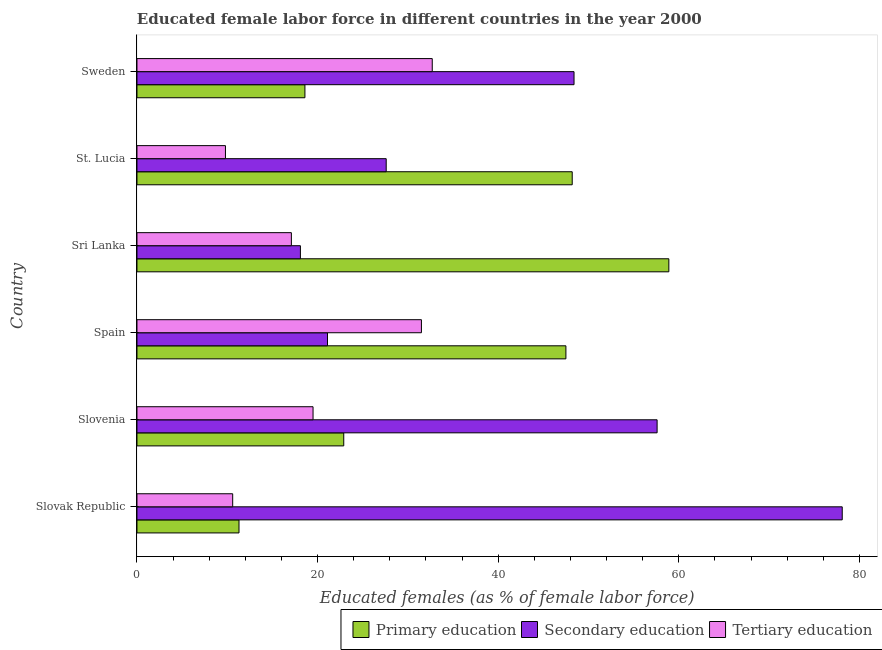Are the number of bars per tick equal to the number of legend labels?
Keep it short and to the point. Yes. How many bars are there on the 4th tick from the bottom?
Make the answer very short. 3. What is the label of the 2nd group of bars from the top?
Make the answer very short. St. Lucia. In how many cases, is the number of bars for a given country not equal to the number of legend labels?
Provide a short and direct response. 0. What is the percentage of female labor force who received secondary education in Sweden?
Provide a short and direct response. 48.4. Across all countries, what is the maximum percentage of female labor force who received tertiary education?
Your response must be concise. 32.7. Across all countries, what is the minimum percentage of female labor force who received secondary education?
Provide a short and direct response. 18.1. In which country was the percentage of female labor force who received secondary education maximum?
Make the answer very short. Slovak Republic. In which country was the percentage of female labor force who received tertiary education minimum?
Offer a terse response. St. Lucia. What is the total percentage of female labor force who received secondary education in the graph?
Ensure brevity in your answer.  250.9. What is the difference between the percentage of female labor force who received primary education in Sri Lanka and that in St. Lucia?
Provide a succinct answer. 10.7. What is the difference between the percentage of female labor force who received tertiary education in Sweden and the percentage of female labor force who received secondary education in Spain?
Offer a terse response. 11.6. What is the average percentage of female labor force who received tertiary education per country?
Provide a succinct answer. 20.2. What is the difference between the percentage of female labor force who received secondary education and percentage of female labor force who received primary education in Sri Lanka?
Your answer should be compact. -40.8. In how many countries, is the percentage of female labor force who received tertiary education greater than 64 %?
Keep it short and to the point. 0. What is the ratio of the percentage of female labor force who received secondary education in Spain to that in Sweden?
Your response must be concise. 0.44. Is the percentage of female labor force who received tertiary education in Sri Lanka less than that in Sweden?
Give a very brief answer. Yes. What is the difference between the highest and the second highest percentage of female labor force who received tertiary education?
Keep it short and to the point. 1.2. What is the difference between the highest and the lowest percentage of female labor force who received secondary education?
Ensure brevity in your answer.  60. What does the 1st bar from the top in Slovak Republic represents?
Offer a very short reply. Tertiary education. What does the 2nd bar from the bottom in Spain represents?
Provide a short and direct response. Secondary education. How many countries are there in the graph?
Make the answer very short. 6. What is the difference between two consecutive major ticks on the X-axis?
Give a very brief answer. 20. Are the values on the major ticks of X-axis written in scientific E-notation?
Provide a short and direct response. No. Does the graph contain any zero values?
Ensure brevity in your answer.  No. Where does the legend appear in the graph?
Provide a succinct answer. Bottom right. What is the title of the graph?
Make the answer very short. Educated female labor force in different countries in the year 2000. What is the label or title of the X-axis?
Keep it short and to the point. Educated females (as % of female labor force). What is the Educated females (as % of female labor force) of Primary education in Slovak Republic?
Your answer should be very brief. 11.3. What is the Educated females (as % of female labor force) in Secondary education in Slovak Republic?
Ensure brevity in your answer.  78.1. What is the Educated females (as % of female labor force) of Tertiary education in Slovak Republic?
Offer a terse response. 10.6. What is the Educated females (as % of female labor force) of Primary education in Slovenia?
Give a very brief answer. 22.9. What is the Educated females (as % of female labor force) of Secondary education in Slovenia?
Provide a succinct answer. 57.6. What is the Educated females (as % of female labor force) of Primary education in Spain?
Give a very brief answer. 47.5. What is the Educated females (as % of female labor force) of Secondary education in Spain?
Your answer should be compact. 21.1. What is the Educated females (as % of female labor force) of Tertiary education in Spain?
Offer a terse response. 31.5. What is the Educated females (as % of female labor force) of Primary education in Sri Lanka?
Offer a terse response. 58.9. What is the Educated females (as % of female labor force) of Secondary education in Sri Lanka?
Your response must be concise. 18.1. What is the Educated females (as % of female labor force) in Tertiary education in Sri Lanka?
Your answer should be compact. 17.1. What is the Educated females (as % of female labor force) in Primary education in St. Lucia?
Provide a short and direct response. 48.2. What is the Educated females (as % of female labor force) in Secondary education in St. Lucia?
Your response must be concise. 27.6. What is the Educated females (as % of female labor force) in Tertiary education in St. Lucia?
Offer a terse response. 9.8. What is the Educated females (as % of female labor force) in Primary education in Sweden?
Your answer should be compact. 18.6. What is the Educated females (as % of female labor force) in Secondary education in Sweden?
Provide a succinct answer. 48.4. What is the Educated females (as % of female labor force) of Tertiary education in Sweden?
Ensure brevity in your answer.  32.7. Across all countries, what is the maximum Educated females (as % of female labor force) in Primary education?
Ensure brevity in your answer.  58.9. Across all countries, what is the maximum Educated females (as % of female labor force) of Secondary education?
Keep it short and to the point. 78.1. Across all countries, what is the maximum Educated females (as % of female labor force) in Tertiary education?
Make the answer very short. 32.7. Across all countries, what is the minimum Educated females (as % of female labor force) in Primary education?
Your answer should be compact. 11.3. Across all countries, what is the minimum Educated females (as % of female labor force) in Secondary education?
Offer a terse response. 18.1. Across all countries, what is the minimum Educated females (as % of female labor force) in Tertiary education?
Provide a succinct answer. 9.8. What is the total Educated females (as % of female labor force) in Primary education in the graph?
Your answer should be very brief. 207.4. What is the total Educated females (as % of female labor force) of Secondary education in the graph?
Your response must be concise. 250.9. What is the total Educated females (as % of female labor force) of Tertiary education in the graph?
Your answer should be very brief. 121.2. What is the difference between the Educated females (as % of female labor force) in Primary education in Slovak Republic and that in Slovenia?
Keep it short and to the point. -11.6. What is the difference between the Educated females (as % of female labor force) of Tertiary education in Slovak Republic and that in Slovenia?
Offer a terse response. -8.9. What is the difference between the Educated females (as % of female labor force) in Primary education in Slovak Republic and that in Spain?
Your response must be concise. -36.2. What is the difference between the Educated females (as % of female labor force) in Secondary education in Slovak Republic and that in Spain?
Ensure brevity in your answer.  57. What is the difference between the Educated females (as % of female labor force) in Tertiary education in Slovak Republic and that in Spain?
Your response must be concise. -20.9. What is the difference between the Educated females (as % of female labor force) of Primary education in Slovak Republic and that in Sri Lanka?
Your answer should be compact. -47.6. What is the difference between the Educated females (as % of female labor force) in Secondary education in Slovak Republic and that in Sri Lanka?
Ensure brevity in your answer.  60. What is the difference between the Educated females (as % of female labor force) of Primary education in Slovak Republic and that in St. Lucia?
Offer a very short reply. -36.9. What is the difference between the Educated females (as % of female labor force) in Secondary education in Slovak Republic and that in St. Lucia?
Offer a very short reply. 50.5. What is the difference between the Educated females (as % of female labor force) in Tertiary education in Slovak Republic and that in St. Lucia?
Provide a succinct answer. 0.8. What is the difference between the Educated females (as % of female labor force) in Secondary education in Slovak Republic and that in Sweden?
Keep it short and to the point. 29.7. What is the difference between the Educated females (as % of female labor force) of Tertiary education in Slovak Republic and that in Sweden?
Offer a very short reply. -22.1. What is the difference between the Educated females (as % of female labor force) of Primary education in Slovenia and that in Spain?
Keep it short and to the point. -24.6. What is the difference between the Educated females (as % of female labor force) of Secondary education in Slovenia and that in Spain?
Your answer should be very brief. 36.5. What is the difference between the Educated females (as % of female labor force) in Primary education in Slovenia and that in Sri Lanka?
Provide a succinct answer. -36. What is the difference between the Educated females (as % of female labor force) of Secondary education in Slovenia and that in Sri Lanka?
Provide a short and direct response. 39.5. What is the difference between the Educated females (as % of female labor force) of Tertiary education in Slovenia and that in Sri Lanka?
Your answer should be compact. 2.4. What is the difference between the Educated females (as % of female labor force) of Primary education in Slovenia and that in St. Lucia?
Make the answer very short. -25.3. What is the difference between the Educated females (as % of female labor force) of Secondary education in Slovenia and that in St. Lucia?
Your answer should be compact. 30. What is the difference between the Educated females (as % of female labor force) in Tertiary education in Slovenia and that in St. Lucia?
Ensure brevity in your answer.  9.7. What is the difference between the Educated females (as % of female labor force) in Tertiary education in Spain and that in Sri Lanka?
Your response must be concise. 14.4. What is the difference between the Educated females (as % of female labor force) in Primary education in Spain and that in St. Lucia?
Offer a terse response. -0.7. What is the difference between the Educated females (as % of female labor force) of Tertiary education in Spain and that in St. Lucia?
Keep it short and to the point. 21.7. What is the difference between the Educated females (as % of female labor force) of Primary education in Spain and that in Sweden?
Keep it short and to the point. 28.9. What is the difference between the Educated females (as % of female labor force) in Secondary education in Spain and that in Sweden?
Your answer should be very brief. -27.3. What is the difference between the Educated females (as % of female labor force) of Tertiary education in Spain and that in Sweden?
Keep it short and to the point. -1.2. What is the difference between the Educated females (as % of female labor force) of Tertiary education in Sri Lanka and that in St. Lucia?
Keep it short and to the point. 7.3. What is the difference between the Educated females (as % of female labor force) of Primary education in Sri Lanka and that in Sweden?
Make the answer very short. 40.3. What is the difference between the Educated females (as % of female labor force) of Secondary education in Sri Lanka and that in Sweden?
Give a very brief answer. -30.3. What is the difference between the Educated females (as % of female labor force) in Tertiary education in Sri Lanka and that in Sweden?
Ensure brevity in your answer.  -15.6. What is the difference between the Educated females (as % of female labor force) in Primary education in St. Lucia and that in Sweden?
Your answer should be very brief. 29.6. What is the difference between the Educated females (as % of female labor force) in Secondary education in St. Lucia and that in Sweden?
Provide a short and direct response. -20.8. What is the difference between the Educated females (as % of female labor force) in Tertiary education in St. Lucia and that in Sweden?
Offer a very short reply. -22.9. What is the difference between the Educated females (as % of female labor force) in Primary education in Slovak Republic and the Educated females (as % of female labor force) in Secondary education in Slovenia?
Make the answer very short. -46.3. What is the difference between the Educated females (as % of female labor force) of Secondary education in Slovak Republic and the Educated females (as % of female labor force) of Tertiary education in Slovenia?
Provide a short and direct response. 58.6. What is the difference between the Educated females (as % of female labor force) of Primary education in Slovak Republic and the Educated females (as % of female labor force) of Secondary education in Spain?
Your answer should be very brief. -9.8. What is the difference between the Educated females (as % of female labor force) in Primary education in Slovak Republic and the Educated females (as % of female labor force) in Tertiary education in Spain?
Make the answer very short. -20.2. What is the difference between the Educated females (as % of female labor force) in Secondary education in Slovak Republic and the Educated females (as % of female labor force) in Tertiary education in Spain?
Your answer should be very brief. 46.6. What is the difference between the Educated females (as % of female labor force) of Primary education in Slovak Republic and the Educated females (as % of female labor force) of Secondary education in Sri Lanka?
Ensure brevity in your answer.  -6.8. What is the difference between the Educated females (as % of female labor force) in Primary education in Slovak Republic and the Educated females (as % of female labor force) in Secondary education in St. Lucia?
Ensure brevity in your answer.  -16.3. What is the difference between the Educated females (as % of female labor force) in Secondary education in Slovak Republic and the Educated females (as % of female labor force) in Tertiary education in St. Lucia?
Your response must be concise. 68.3. What is the difference between the Educated females (as % of female labor force) of Primary education in Slovak Republic and the Educated females (as % of female labor force) of Secondary education in Sweden?
Your response must be concise. -37.1. What is the difference between the Educated females (as % of female labor force) in Primary education in Slovak Republic and the Educated females (as % of female labor force) in Tertiary education in Sweden?
Provide a succinct answer. -21.4. What is the difference between the Educated females (as % of female labor force) in Secondary education in Slovak Republic and the Educated females (as % of female labor force) in Tertiary education in Sweden?
Your answer should be compact. 45.4. What is the difference between the Educated females (as % of female labor force) of Primary education in Slovenia and the Educated females (as % of female labor force) of Secondary education in Spain?
Your answer should be compact. 1.8. What is the difference between the Educated females (as % of female labor force) in Primary education in Slovenia and the Educated females (as % of female labor force) in Tertiary education in Spain?
Provide a succinct answer. -8.6. What is the difference between the Educated females (as % of female labor force) in Secondary education in Slovenia and the Educated females (as % of female labor force) in Tertiary education in Spain?
Offer a terse response. 26.1. What is the difference between the Educated females (as % of female labor force) in Primary education in Slovenia and the Educated females (as % of female labor force) in Tertiary education in Sri Lanka?
Give a very brief answer. 5.8. What is the difference between the Educated females (as % of female labor force) in Secondary education in Slovenia and the Educated females (as % of female labor force) in Tertiary education in Sri Lanka?
Your answer should be compact. 40.5. What is the difference between the Educated females (as % of female labor force) of Primary education in Slovenia and the Educated females (as % of female labor force) of Tertiary education in St. Lucia?
Offer a terse response. 13.1. What is the difference between the Educated females (as % of female labor force) of Secondary education in Slovenia and the Educated females (as % of female labor force) of Tertiary education in St. Lucia?
Offer a very short reply. 47.8. What is the difference between the Educated females (as % of female labor force) of Primary education in Slovenia and the Educated females (as % of female labor force) of Secondary education in Sweden?
Make the answer very short. -25.5. What is the difference between the Educated females (as % of female labor force) in Primary education in Slovenia and the Educated females (as % of female labor force) in Tertiary education in Sweden?
Give a very brief answer. -9.8. What is the difference between the Educated females (as % of female labor force) of Secondary education in Slovenia and the Educated females (as % of female labor force) of Tertiary education in Sweden?
Make the answer very short. 24.9. What is the difference between the Educated females (as % of female labor force) of Primary education in Spain and the Educated females (as % of female labor force) of Secondary education in Sri Lanka?
Your answer should be compact. 29.4. What is the difference between the Educated females (as % of female labor force) in Primary education in Spain and the Educated females (as % of female labor force) in Tertiary education in Sri Lanka?
Give a very brief answer. 30.4. What is the difference between the Educated females (as % of female labor force) of Primary education in Spain and the Educated females (as % of female labor force) of Secondary education in St. Lucia?
Give a very brief answer. 19.9. What is the difference between the Educated females (as % of female labor force) in Primary education in Spain and the Educated females (as % of female labor force) in Tertiary education in St. Lucia?
Ensure brevity in your answer.  37.7. What is the difference between the Educated females (as % of female labor force) of Secondary education in Spain and the Educated females (as % of female labor force) of Tertiary education in St. Lucia?
Ensure brevity in your answer.  11.3. What is the difference between the Educated females (as % of female labor force) in Primary education in Spain and the Educated females (as % of female labor force) in Tertiary education in Sweden?
Keep it short and to the point. 14.8. What is the difference between the Educated females (as % of female labor force) in Primary education in Sri Lanka and the Educated females (as % of female labor force) in Secondary education in St. Lucia?
Offer a very short reply. 31.3. What is the difference between the Educated females (as % of female labor force) of Primary education in Sri Lanka and the Educated females (as % of female labor force) of Tertiary education in St. Lucia?
Your answer should be very brief. 49.1. What is the difference between the Educated females (as % of female labor force) in Secondary education in Sri Lanka and the Educated females (as % of female labor force) in Tertiary education in St. Lucia?
Offer a terse response. 8.3. What is the difference between the Educated females (as % of female labor force) of Primary education in Sri Lanka and the Educated females (as % of female labor force) of Secondary education in Sweden?
Offer a terse response. 10.5. What is the difference between the Educated females (as % of female labor force) of Primary education in Sri Lanka and the Educated females (as % of female labor force) of Tertiary education in Sweden?
Offer a terse response. 26.2. What is the difference between the Educated females (as % of female labor force) in Secondary education in Sri Lanka and the Educated females (as % of female labor force) in Tertiary education in Sweden?
Provide a short and direct response. -14.6. What is the difference between the Educated females (as % of female labor force) of Primary education in St. Lucia and the Educated females (as % of female labor force) of Tertiary education in Sweden?
Provide a short and direct response. 15.5. What is the difference between the Educated females (as % of female labor force) in Secondary education in St. Lucia and the Educated females (as % of female labor force) in Tertiary education in Sweden?
Keep it short and to the point. -5.1. What is the average Educated females (as % of female labor force) in Primary education per country?
Your answer should be compact. 34.57. What is the average Educated females (as % of female labor force) of Secondary education per country?
Provide a short and direct response. 41.82. What is the average Educated females (as % of female labor force) of Tertiary education per country?
Offer a very short reply. 20.2. What is the difference between the Educated females (as % of female labor force) of Primary education and Educated females (as % of female labor force) of Secondary education in Slovak Republic?
Keep it short and to the point. -66.8. What is the difference between the Educated females (as % of female labor force) of Secondary education and Educated females (as % of female labor force) of Tertiary education in Slovak Republic?
Your response must be concise. 67.5. What is the difference between the Educated females (as % of female labor force) of Primary education and Educated females (as % of female labor force) of Secondary education in Slovenia?
Your answer should be very brief. -34.7. What is the difference between the Educated females (as % of female labor force) in Secondary education and Educated females (as % of female labor force) in Tertiary education in Slovenia?
Offer a very short reply. 38.1. What is the difference between the Educated females (as % of female labor force) of Primary education and Educated females (as % of female labor force) of Secondary education in Spain?
Provide a short and direct response. 26.4. What is the difference between the Educated females (as % of female labor force) in Primary education and Educated females (as % of female labor force) in Tertiary education in Spain?
Offer a very short reply. 16. What is the difference between the Educated females (as % of female labor force) in Secondary education and Educated females (as % of female labor force) in Tertiary education in Spain?
Offer a terse response. -10.4. What is the difference between the Educated females (as % of female labor force) in Primary education and Educated females (as % of female labor force) in Secondary education in Sri Lanka?
Keep it short and to the point. 40.8. What is the difference between the Educated females (as % of female labor force) of Primary education and Educated females (as % of female labor force) of Tertiary education in Sri Lanka?
Your answer should be very brief. 41.8. What is the difference between the Educated females (as % of female labor force) in Primary education and Educated females (as % of female labor force) in Secondary education in St. Lucia?
Offer a terse response. 20.6. What is the difference between the Educated females (as % of female labor force) in Primary education and Educated females (as % of female labor force) in Tertiary education in St. Lucia?
Your answer should be very brief. 38.4. What is the difference between the Educated females (as % of female labor force) in Primary education and Educated females (as % of female labor force) in Secondary education in Sweden?
Provide a succinct answer. -29.8. What is the difference between the Educated females (as % of female labor force) in Primary education and Educated females (as % of female labor force) in Tertiary education in Sweden?
Provide a short and direct response. -14.1. What is the difference between the Educated females (as % of female labor force) in Secondary education and Educated females (as % of female labor force) in Tertiary education in Sweden?
Your answer should be compact. 15.7. What is the ratio of the Educated females (as % of female labor force) in Primary education in Slovak Republic to that in Slovenia?
Provide a short and direct response. 0.49. What is the ratio of the Educated females (as % of female labor force) of Secondary education in Slovak Republic to that in Slovenia?
Provide a succinct answer. 1.36. What is the ratio of the Educated females (as % of female labor force) in Tertiary education in Slovak Republic to that in Slovenia?
Ensure brevity in your answer.  0.54. What is the ratio of the Educated females (as % of female labor force) of Primary education in Slovak Republic to that in Spain?
Your answer should be very brief. 0.24. What is the ratio of the Educated females (as % of female labor force) in Secondary education in Slovak Republic to that in Spain?
Ensure brevity in your answer.  3.7. What is the ratio of the Educated females (as % of female labor force) of Tertiary education in Slovak Republic to that in Spain?
Offer a terse response. 0.34. What is the ratio of the Educated females (as % of female labor force) of Primary education in Slovak Republic to that in Sri Lanka?
Give a very brief answer. 0.19. What is the ratio of the Educated females (as % of female labor force) in Secondary education in Slovak Republic to that in Sri Lanka?
Provide a short and direct response. 4.31. What is the ratio of the Educated females (as % of female labor force) in Tertiary education in Slovak Republic to that in Sri Lanka?
Make the answer very short. 0.62. What is the ratio of the Educated females (as % of female labor force) in Primary education in Slovak Republic to that in St. Lucia?
Give a very brief answer. 0.23. What is the ratio of the Educated females (as % of female labor force) of Secondary education in Slovak Republic to that in St. Lucia?
Give a very brief answer. 2.83. What is the ratio of the Educated females (as % of female labor force) in Tertiary education in Slovak Republic to that in St. Lucia?
Offer a terse response. 1.08. What is the ratio of the Educated females (as % of female labor force) in Primary education in Slovak Republic to that in Sweden?
Ensure brevity in your answer.  0.61. What is the ratio of the Educated females (as % of female labor force) in Secondary education in Slovak Republic to that in Sweden?
Ensure brevity in your answer.  1.61. What is the ratio of the Educated females (as % of female labor force) of Tertiary education in Slovak Republic to that in Sweden?
Provide a succinct answer. 0.32. What is the ratio of the Educated females (as % of female labor force) of Primary education in Slovenia to that in Spain?
Your answer should be compact. 0.48. What is the ratio of the Educated females (as % of female labor force) in Secondary education in Slovenia to that in Spain?
Make the answer very short. 2.73. What is the ratio of the Educated females (as % of female labor force) in Tertiary education in Slovenia to that in Spain?
Offer a very short reply. 0.62. What is the ratio of the Educated females (as % of female labor force) in Primary education in Slovenia to that in Sri Lanka?
Make the answer very short. 0.39. What is the ratio of the Educated females (as % of female labor force) in Secondary education in Slovenia to that in Sri Lanka?
Offer a terse response. 3.18. What is the ratio of the Educated females (as % of female labor force) in Tertiary education in Slovenia to that in Sri Lanka?
Your response must be concise. 1.14. What is the ratio of the Educated females (as % of female labor force) in Primary education in Slovenia to that in St. Lucia?
Offer a very short reply. 0.48. What is the ratio of the Educated females (as % of female labor force) of Secondary education in Slovenia to that in St. Lucia?
Make the answer very short. 2.09. What is the ratio of the Educated females (as % of female labor force) of Tertiary education in Slovenia to that in St. Lucia?
Keep it short and to the point. 1.99. What is the ratio of the Educated females (as % of female labor force) of Primary education in Slovenia to that in Sweden?
Your answer should be very brief. 1.23. What is the ratio of the Educated females (as % of female labor force) of Secondary education in Slovenia to that in Sweden?
Your answer should be compact. 1.19. What is the ratio of the Educated females (as % of female labor force) in Tertiary education in Slovenia to that in Sweden?
Ensure brevity in your answer.  0.6. What is the ratio of the Educated females (as % of female labor force) of Primary education in Spain to that in Sri Lanka?
Provide a short and direct response. 0.81. What is the ratio of the Educated females (as % of female labor force) in Secondary education in Spain to that in Sri Lanka?
Ensure brevity in your answer.  1.17. What is the ratio of the Educated females (as % of female labor force) in Tertiary education in Spain to that in Sri Lanka?
Offer a very short reply. 1.84. What is the ratio of the Educated females (as % of female labor force) in Primary education in Spain to that in St. Lucia?
Offer a very short reply. 0.99. What is the ratio of the Educated females (as % of female labor force) in Secondary education in Spain to that in St. Lucia?
Offer a terse response. 0.76. What is the ratio of the Educated females (as % of female labor force) of Tertiary education in Spain to that in St. Lucia?
Your answer should be compact. 3.21. What is the ratio of the Educated females (as % of female labor force) of Primary education in Spain to that in Sweden?
Offer a terse response. 2.55. What is the ratio of the Educated females (as % of female labor force) in Secondary education in Spain to that in Sweden?
Your answer should be very brief. 0.44. What is the ratio of the Educated females (as % of female labor force) of Tertiary education in Spain to that in Sweden?
Ensure brevity in your answer.  0.96. What is the ratio of the Educated females (as % of female labor force) in Primary education in Sri Lanka to that in St. Lucia?
Your answer should be compact. 1.22. What is the ratio of the Educated females (as % of female labor force) in Secondary education in Sri Lanka to that in St. Lucia?
Your response must be concise. 0.66. What is the ratio of the Educated females (as % of female labor force) of Tertiary education in Sri Lanka to that in St. Lucia?
Offer a very short reply. 1.74. What is the ratio of the Educated females (as % of female labor force) of Primary education in Sri Lanka to that in Sweden?
Make the answer very short. 3.17. What is the ratio of the Educated females (as % of female labor force) of Secondary education in Sri Lanka to that in Sweden?
Make the answer very short. 0.37. What is the ratio of the Educated females (as % of female labor force) in Tertiary education in Sri Lanka to that in Sweden?
Keep it short and to the point. 0.52. What is the ratio of the Educated females (as % of female labor force) of Primary education in St. Lucia to that in Sweden?
Offer a terse response. 2.59. What is the ratio of the Educated females (as % of female labor force) of Secondary education in St. Lucia to that in Sweden?
Offer a terse response. 0.57. What is the ratio of the Educated females (as % of female labor force) of Tertiary education in St. Lucia to that in Sweden?
Your answer should be very brief. 0.3. What is the difference between the highest and the second highest Educated females (as % of female labor force) of Primary education?
Provide a succinct answer. 10.7. What is the difference between the highest and the second highest Educated females (as % of female labor force) of Secondary education?
Offer a terse response. 20.5. What is the difference between the highest and the second highest Educated females (as % of female labor force) in Tertiary education?
Provide a succinct answer. 1.2. What is the difference between the highest and the lowest Educated females (as % of female labor force) of Primary education?
Your response must be concise. 47.6. What is the difference between the highest and the lowest Educated females (as % of female labor force) of Secondary education?
Offer a terse response. 60. What is the difference between the highest and the lowest Educated females (as % of female labor force) of Tertiary education?
Offer a very short reply. 22.9. 